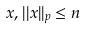Convert formula to latex. <formula><loc_0><loc_0><loc_500><loc_500>x , | | x | | _ { p } \leq n</formula> 